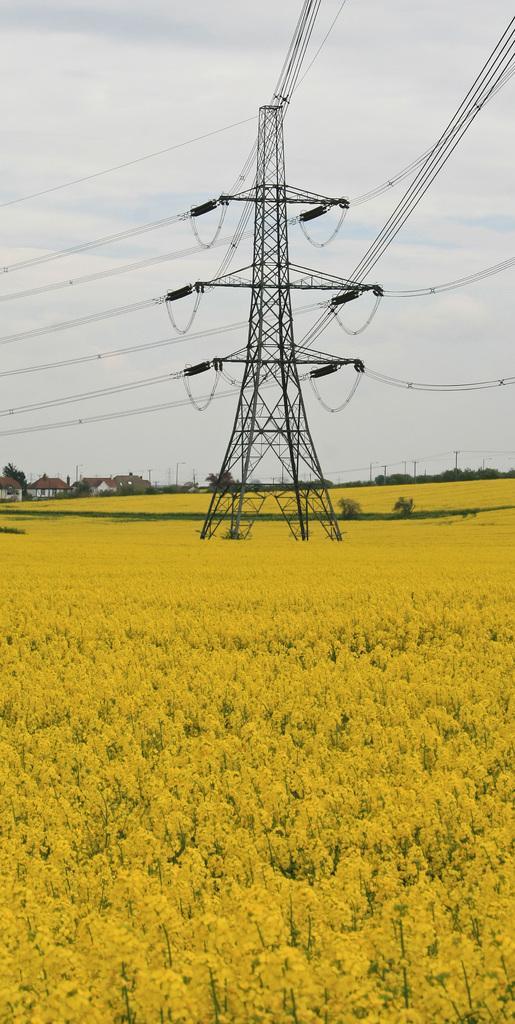Describe this image in one or two sentences. This image consists of a transmission pole. To which there are many wires. At the bottom, we can see the plants in yellow color. At the top, there are clouds in the sky. 